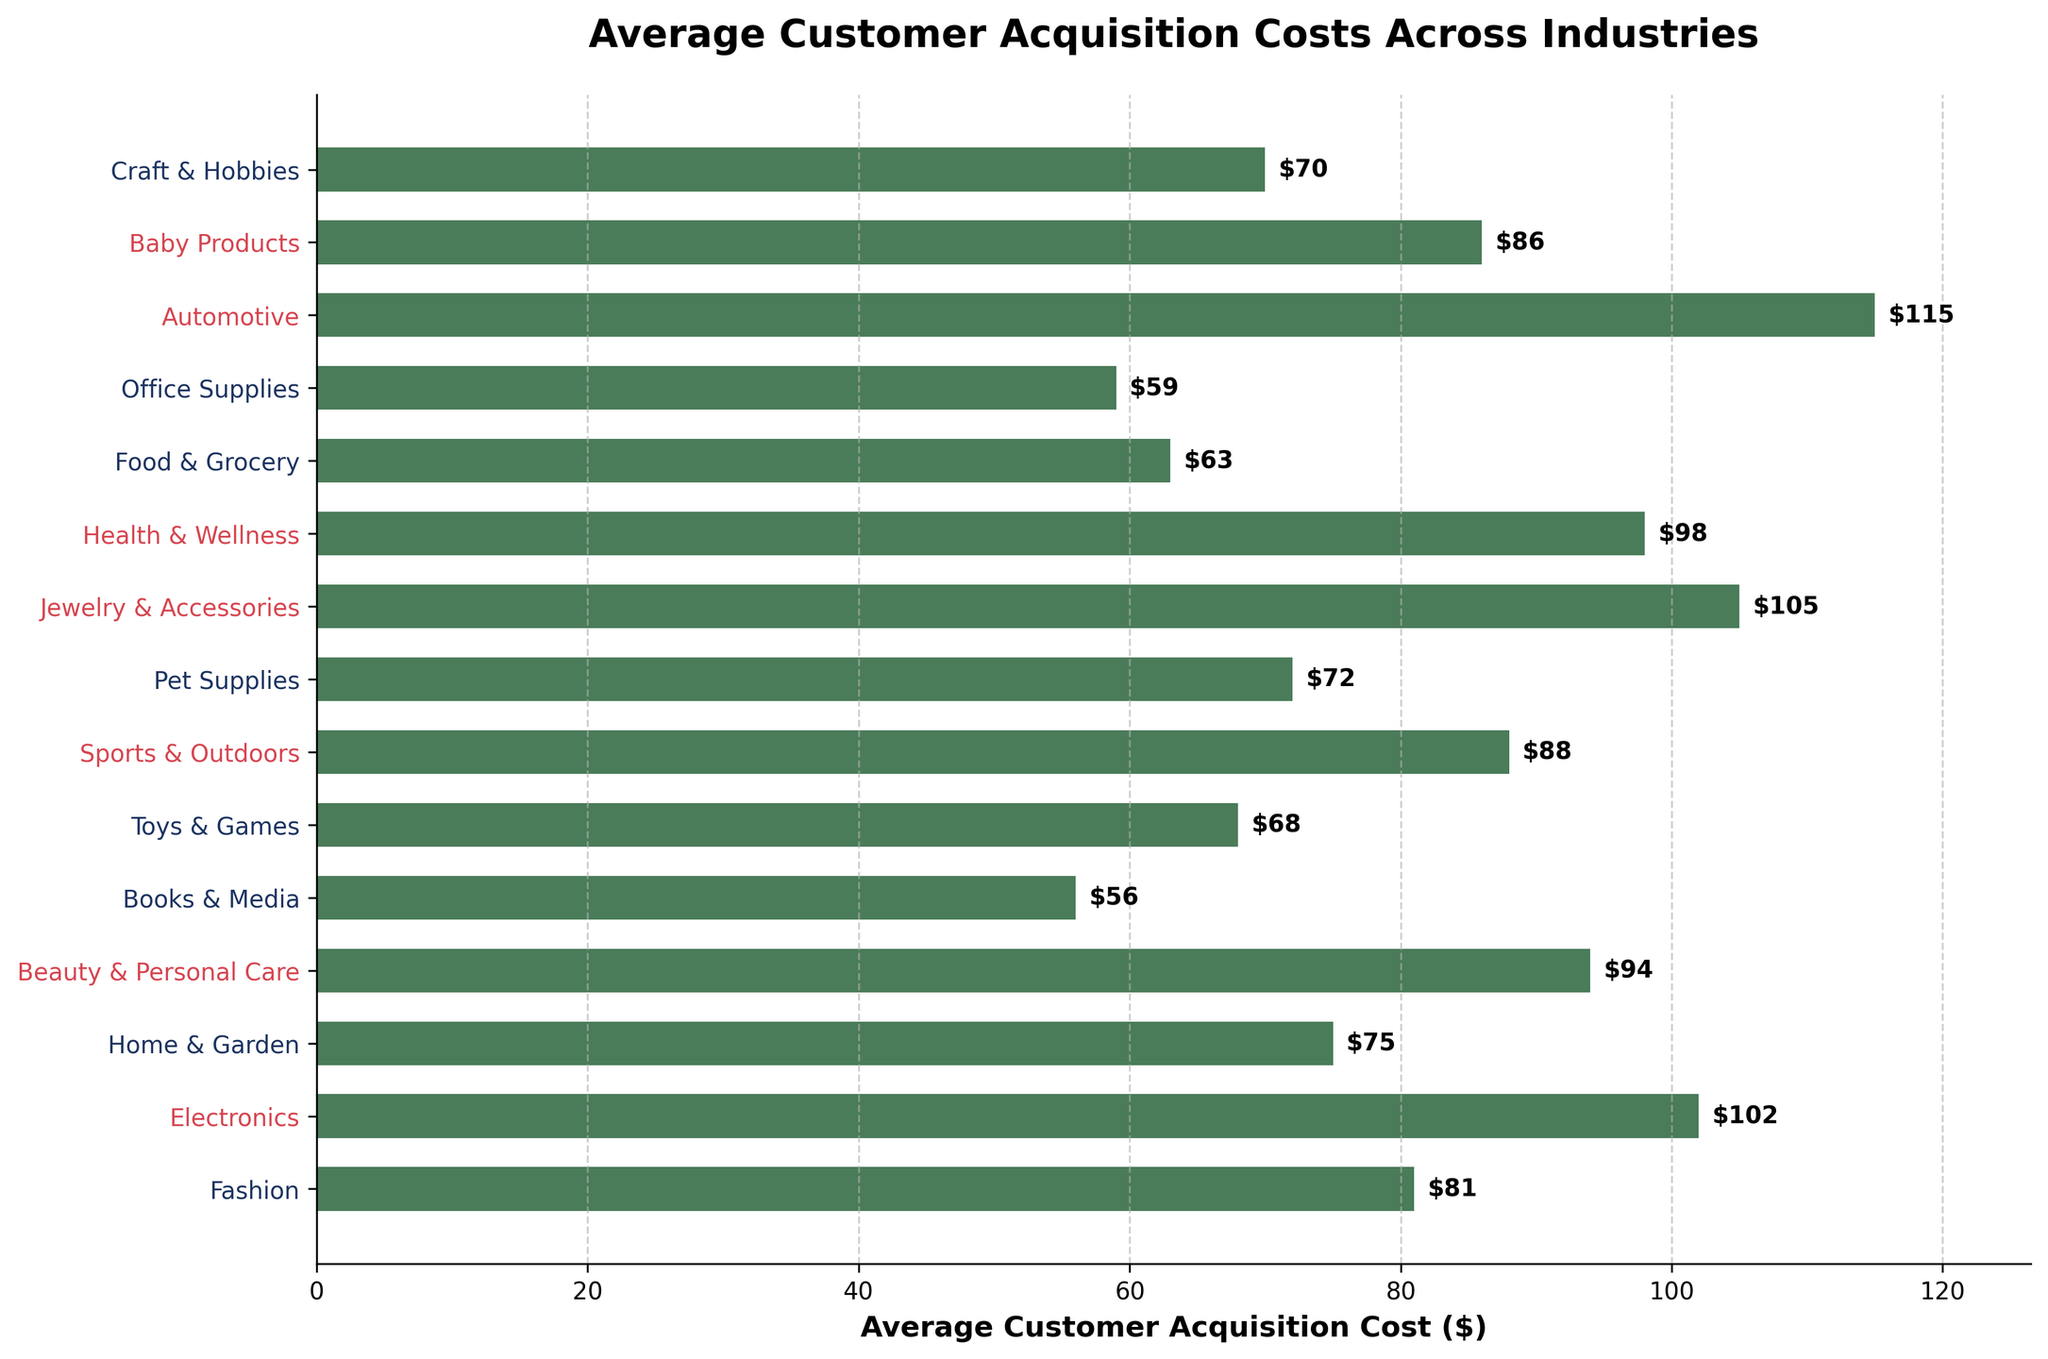Which industry has the highest average customer acquisition cost? Refer to the plot and identify the bar with the greatest length. The Automotive industry bar is the longest.
Answer: Automotive Which industry has the lowest average customer acquisition cost? Look for the shortest bar in the plot. The shortest bar represents the Books & Media industry.
Answer: Books & Media How much more does it cost to acquire a customer in the Jewelry & Accessories industry compared to the Fashion industry? Find the values for both industries: $105 for Jewelry & Accessories and $81 for Fashion. Subtract $81 from $105.
Answer: $24 What is the median cost of customer acquisition across the industries? Order the costs from least to greatest: 56, 59, 63, 68, 70, 72, 75, 81, 86, 88, 94, 98, 102, 105, 115. The median is the middle value, which is the 8th value in this sorted list.
Answer: $81 Which industries have customer acquisition costs greater than $90? Identify bars with lengths corresponding to values greater than $90. These industries are Electronics, Beauty & Personal Care, Jewelry & Accessories, Health & Wellness, and Automotive.
Answer: Electronics, Beauty & Personal Care, Jewelry & Accessories, Health & Wellness, Automotive What is the difference in customer acquisition cost between the top two most expensive industries? The top two costs are $115 (Automotive) and $105 (Jewelry & Accessories). Subtract $105 from $115.
Answer: $10 How does the acquisition cost of the Sports & Outdoors industry compare with the Pet Supplies industry? The cost for Sports & Outdoors is $88 and for Pet Supplies is $72. $88 is greater than $72.
Answer: Higher If the median value of the customer acquisition costs is $81, how many industries have costs higher than the median? Count the industries with values above $81: Home & Garden, Fashion, Baby Products, Sports & Outdoors, Beauty & Personal Care, Health & Wellness, Electronics, Jewelry & Accessories, and Automotive.
Answer: 9 What is the average customer acquisition cost for industries below the median value? Identify costs below $81: 56, 59, 63, 68, 70, 72, 75. Sum these (56 + 59 + 63 + 68 + 70 + 72 + 75 = 463) and divide by the number of values (463 / 7).
Answer: $66 